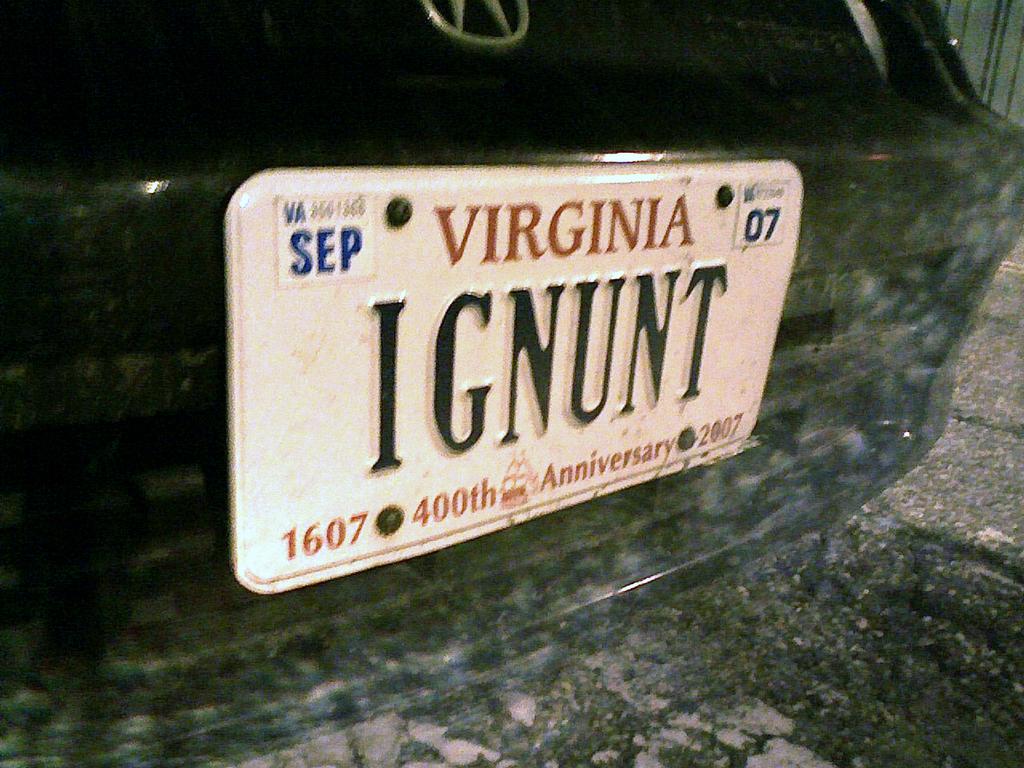What state issued this license plate?
Provide a short and direct response. Virginia. What month do the plates expire?
Provide a succinct answer. Sep. 